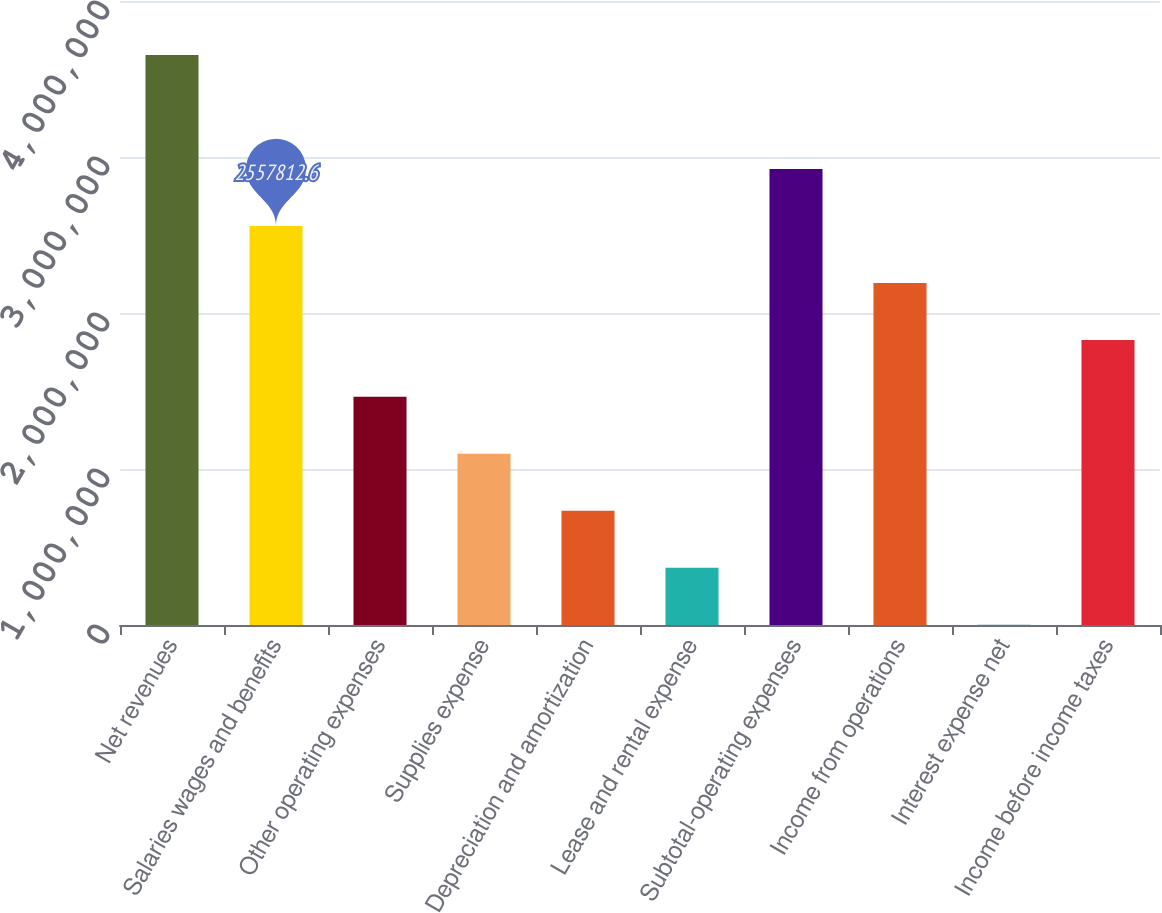Convert chart to OTSL. <chart><loc_0><loc_0><loc_500><loc_500><bar_chart><fcel>Net revenues<fcel>Salaries wages and benefits<fcel>Other operating expenses<fcel>Supplies expense<fcel>Depreciation and amortization<fcel>Lease and rental expense<fcel>Subtotal-operating expenses<fcel>Income from operations<fcel>Interest expense net<fcel>Income before income taxes<nl><fcel>3.65313e+06<fcel>2.55781e+06<fcel>1.4625e+06<fcel>1.09739e+06<fcel>732289<fcel>367184<fcel>2.92292e+06<fcel>2.19271e+06<fcel>2079<fcel>1.8276e+06<nl></chart> 